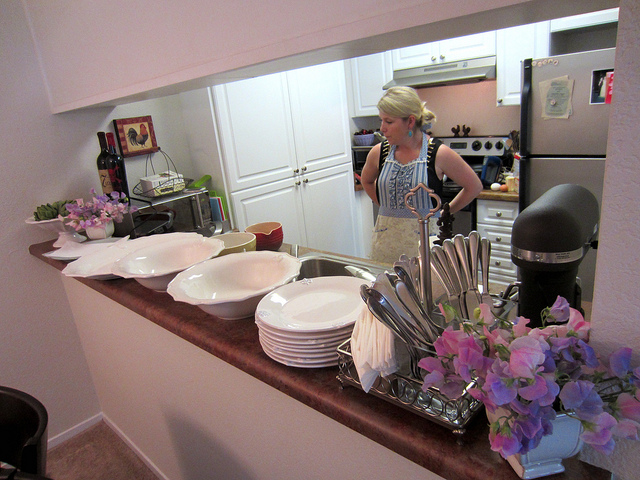<image>What color are the flowers on the left wall? There are no flowers on the left wall in the image. However, if there were flowers, responses suggest they may be purplish pink. What appliance has been used? It is ambiguous which appliance has been used. It could be a mixer, oven, dishwasher, sink, stove, or none at all. What chips are on the counter? There are no chips on the counter. What chips are on the counter? There are no chips on the counter. What color are the flowers on the left wall? I am not sure what color the flowers on the left wall are. However, it appears to be some shade of purple or pink. What appliance has been used? There is no sure answer to what appliance has been used. It could be either a mixer, oven, dishwasher, sink, or stove. 